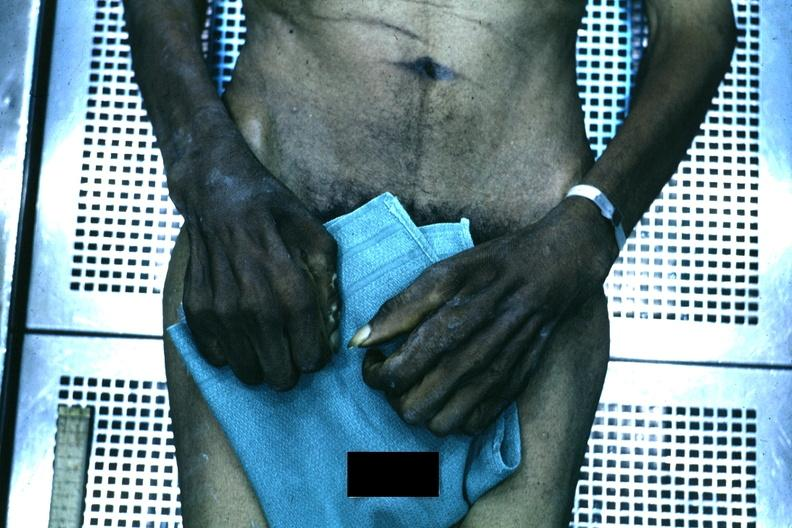what does this image show?
Answer the question using a single word or phrase. Good example of muscle atrophy said to be due to syringomyelia 